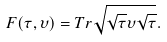Convert formula to latex. <formula><loc_0><loc_0><loc_500><loc_500>F ( \tau , \upsilon ) = T r \sqrt { \sqrt { \tau } \upsilon \sqrt { \tau } } .</formula> 